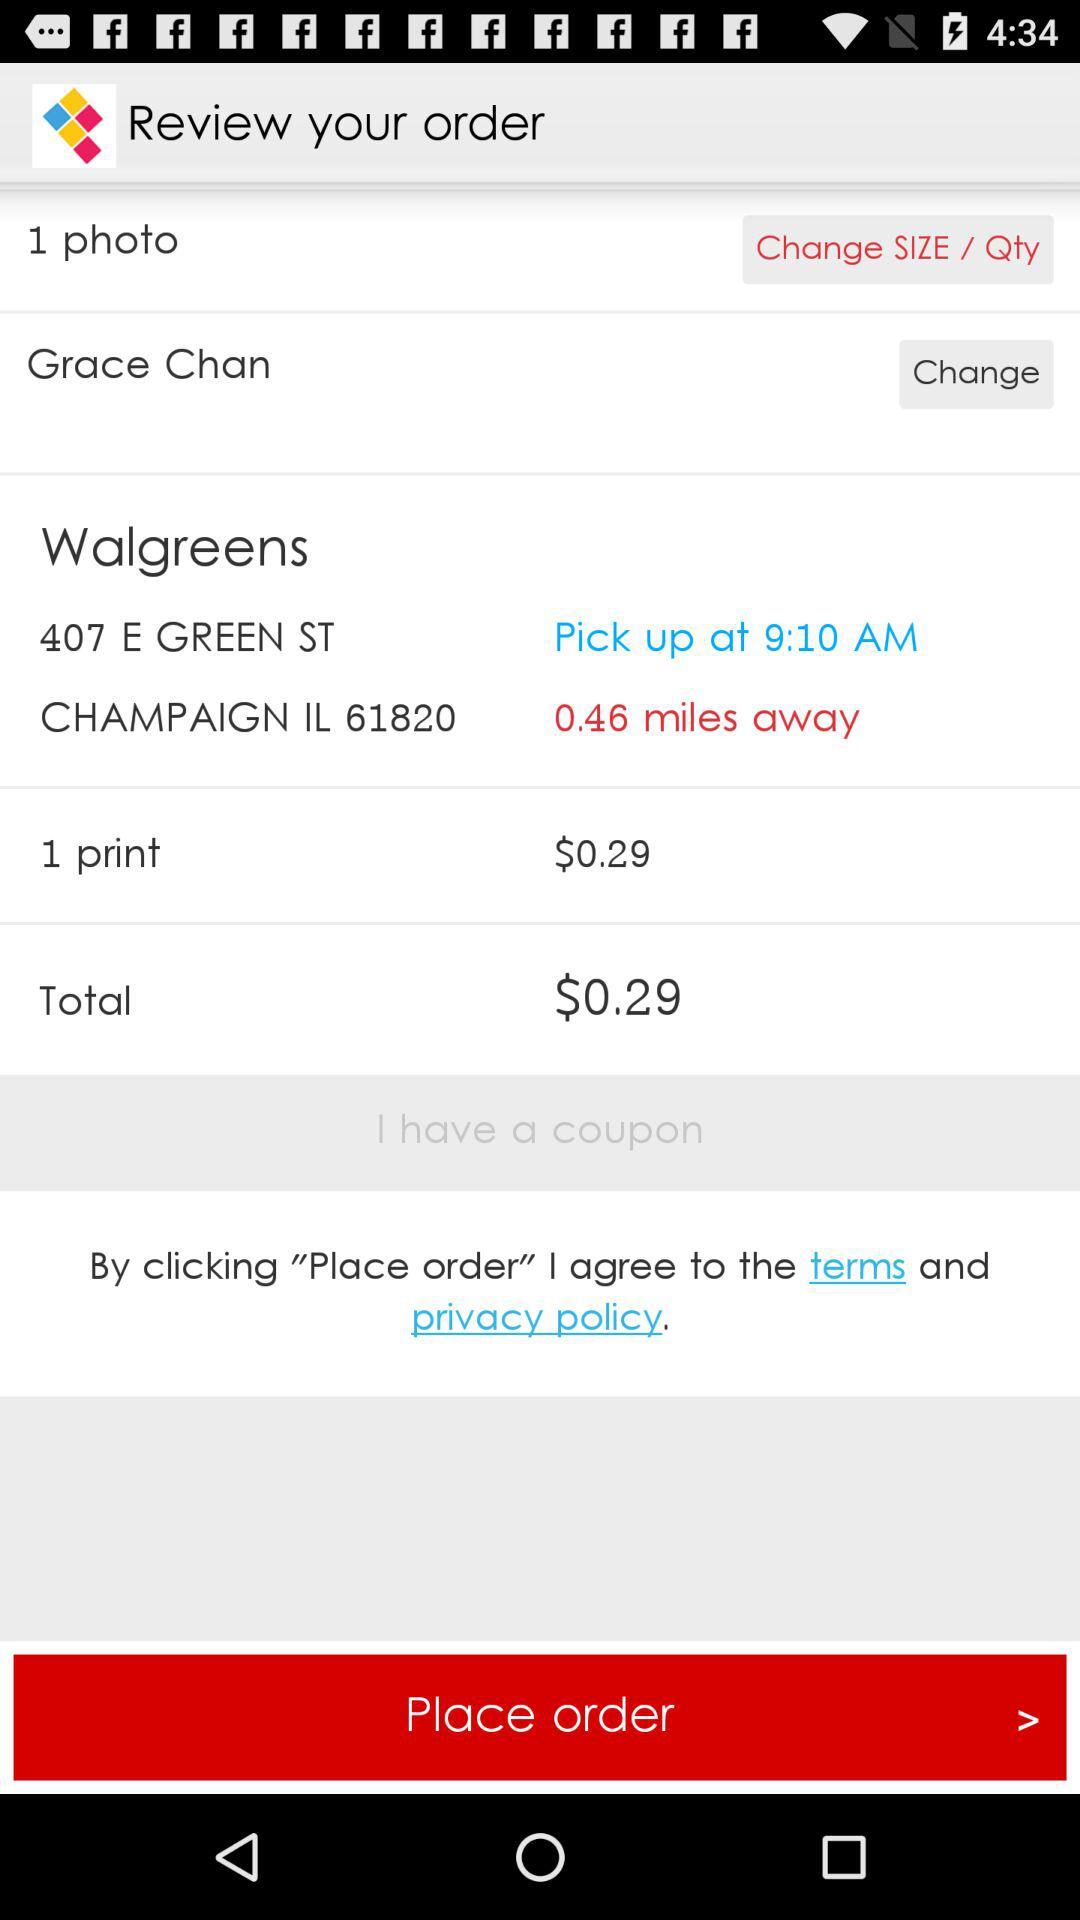What is the total amount? The total amount is $0.29. 